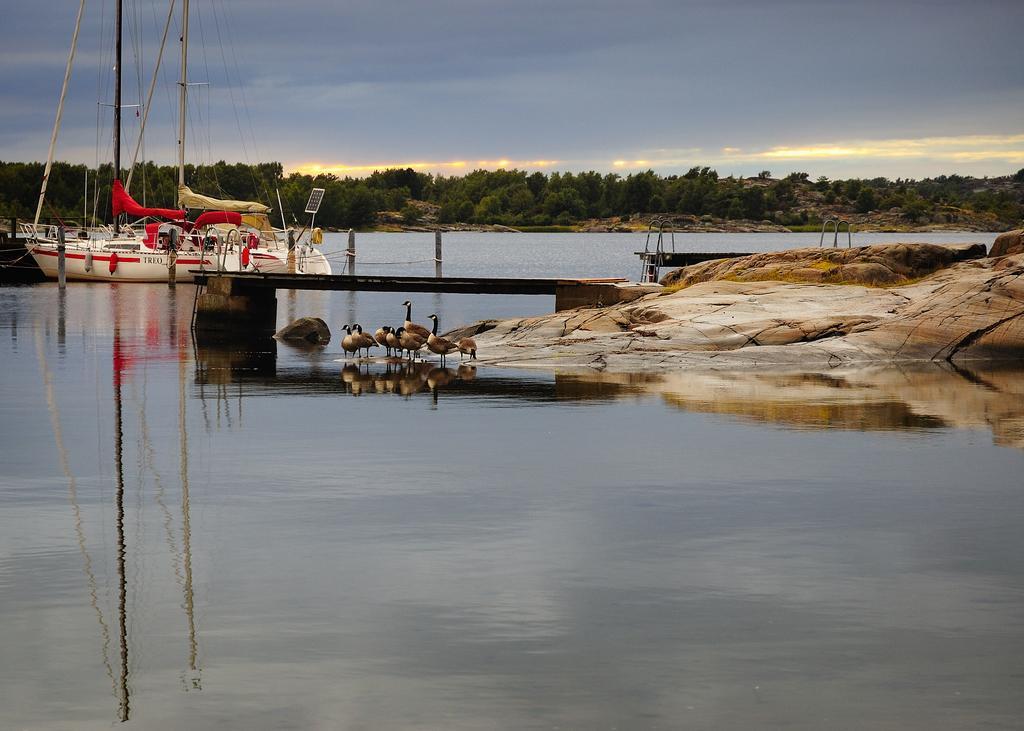How would you summarize this image in a sentence or two? In this image I can see the water, few birds which are brown and black in color are standing on the surface of the water, a bridge, few poles, a rocky surface and a boat which is white and red in color on the surface of the water. In the background I can see few trees and the sky. 